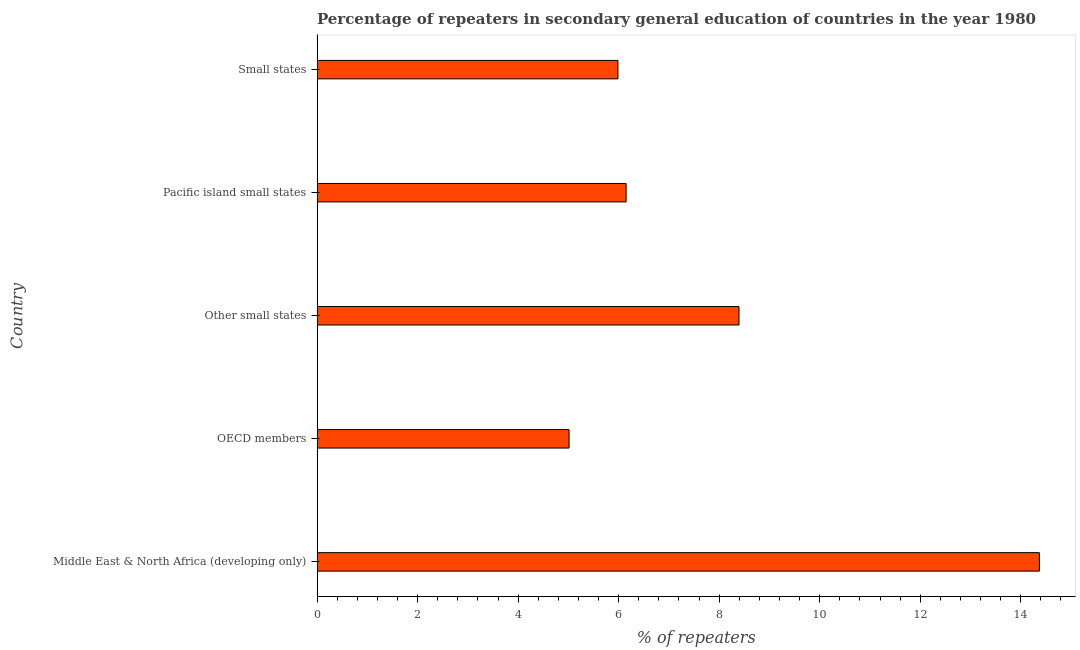Does the graph contain grids?
Provide a succinct answer. No. What is the title of the graph?
Your answer should be compact. Percentage of repeaters in secondary general education of countries in the year 1980. What is the label or title of the X-axis?
Make the answer very short. % of repeaters. What is the label or title of the Y-axis?
Your response must be concise. Country. What is the percentage of repeaters in Other small states?
Provide a succinct answer. 8.39. Across all countries, what is the maximum percentage of repeaters?
Offer a very short reply. 14.37. Across all countries, what is the minimum percentage of repeaters?
Keep it short and to the point. 5.01. In which country was the percentage of repeaters maximum?
Make the answer very short. Middle East & North Africa (developing only). In which country was the percentage of repeaters minimum?
Offer a very short reply. OECD members. What is the sum of the percentage of repeaters?
Offer a very short reply. 39.91. What is the difference between the percentage of repeaters in Pacific island small states and Small states?
Your answer should be compact. 0.16. What is the average percentage of repeaters per country?
Keep it short and to the point. 7.98. What is the median percentage of repeaters?
Your answer should be compact. 6.15. What is the ratio of the percentage of repeaters in Middle East & North Africa (developing only) to that in Small states?
Provide a short and direct response. 2.4. Is the percentage of repeaters in Middle East & North Africa (developing only) less than that in OECD members?
Keep it short and to the point. No. What is the difference between the highest and the second highest percentage of repeaters?
Your answer should be compact. 5.98. What is the difference between the highest and the lowest percentage of repeaters?
Make the answer very short. 9.36. In how many countries, is the percentage of repeaters greater than the average percentage of repeaters taken over all countries?
Make the answer very short. 2. How many bars are there?
Your response must be concise. 5. How many countries are there in the graph?
Provide a short and direct response. 5. What is the difference between two consecutive major ticks on the X-axis?
Provide a short and direct response. 2. What is the % of repeaters in Middle East & North Africa (developing only)?
Offer a very short reply. 14.37. What is the % of repeaters in OECD members?
Your answer should be very brief. 5.01. What is the % of repeaters in Other small states?
Your response must be concise. 8.39. What is the % of repeaters of Pacific island small states?
Offer a terse response. 6.15. What is the % of repeaters of Small states?
Keep it short and to the point. 5.99. What is the difference between the % of repeaters in Middle East & North Africa (developing only) and OECD members?
Keep it short and to the point. 9.36. What is the difference between the % of repeaters in Middle East & North Africa (developing only) and Other small states?
Ensure brevity in your answer.  5.98. What is the difference between the % of repeaters in Middle East & North Africa (developing only) and Pacific island small states?
Make the answer very short. 8.22. What is the difference between the % of repeaters in Middle East & North Africa (developing only) and Small states?
Offer a very short reply. 8.38. What is the difference between the % of repeaters in OECD members and Other small states?
Your answer should be very brief. -3.38. What is the difference between the % of repeaters in OECD members and Pacific island small states?
Your answer should be compact. -1.13. What is the difference between the % of repeaters in OECD members and Small states?
Keep it short and to the point. -0.97. What is the difference between the % of repeaters in Other small states and Pacific island small states?
Your response must be concise. 2.25. What is the difference between the % of repeaters in Other small states and Small states?
Ensure brevity in your answer.  2.41. What is the difference between the % of repeaters in Pacific island small states and Small states?
Give a very brief answer. 0.16. What is the ratio of the % of repeaters in Middle East & North Africa (developing only) to that in OECD members?
Your answer should be very brief. 2.87. What is the ratio of the % of repeaters in Middle East & North Africa (developing only) to that in Other small states?
Your answer should be compact. 1.71. What is the ratio of the % of repeaters in Middle East & North Africa (developing only) to that in Pacific island small states?
Your response must be concise. 2.34. What is the ratio of the % of repeaters in Middle East & North Africa (developing only) to that in Small states?
Make the answer very short. 2.4. What is the ratio of the % of repeaters in OECD members to that in Other small states?
Make the answer very short. 0.6. What is the ratio of the % of repeaters in OECD members to that in Pacific island small states?
Provide a short and direct response. 0.81. What is the ratio of the % of repeaters in OECD members to that in Small states?
Keep it short and to the point. 0.84. What is the ratio of the % of repeaters in Other small states to that in Pacific island small states?
Offer a very short reply. 1.36. What is the ratio of the % of repeaters in Other small states to that in Small states?
Give a very brief answer. 1.4. What is the ratio of the % of repeaters in Pacific island small states to that in Small states?
Keep it short and to the point. 1.03. 